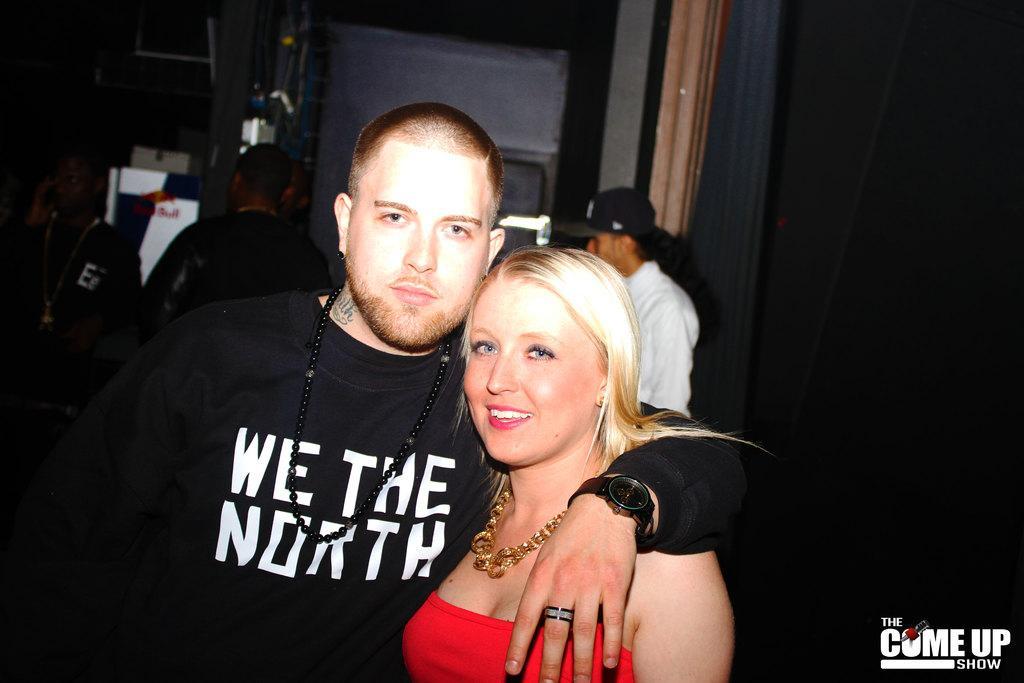Can you describe this image briefly? In the picture we can see a man and woman standing together and man is wearing a black T-shirt and woman is wearing a red dress and necklace and in the background we can see some people are standing. 